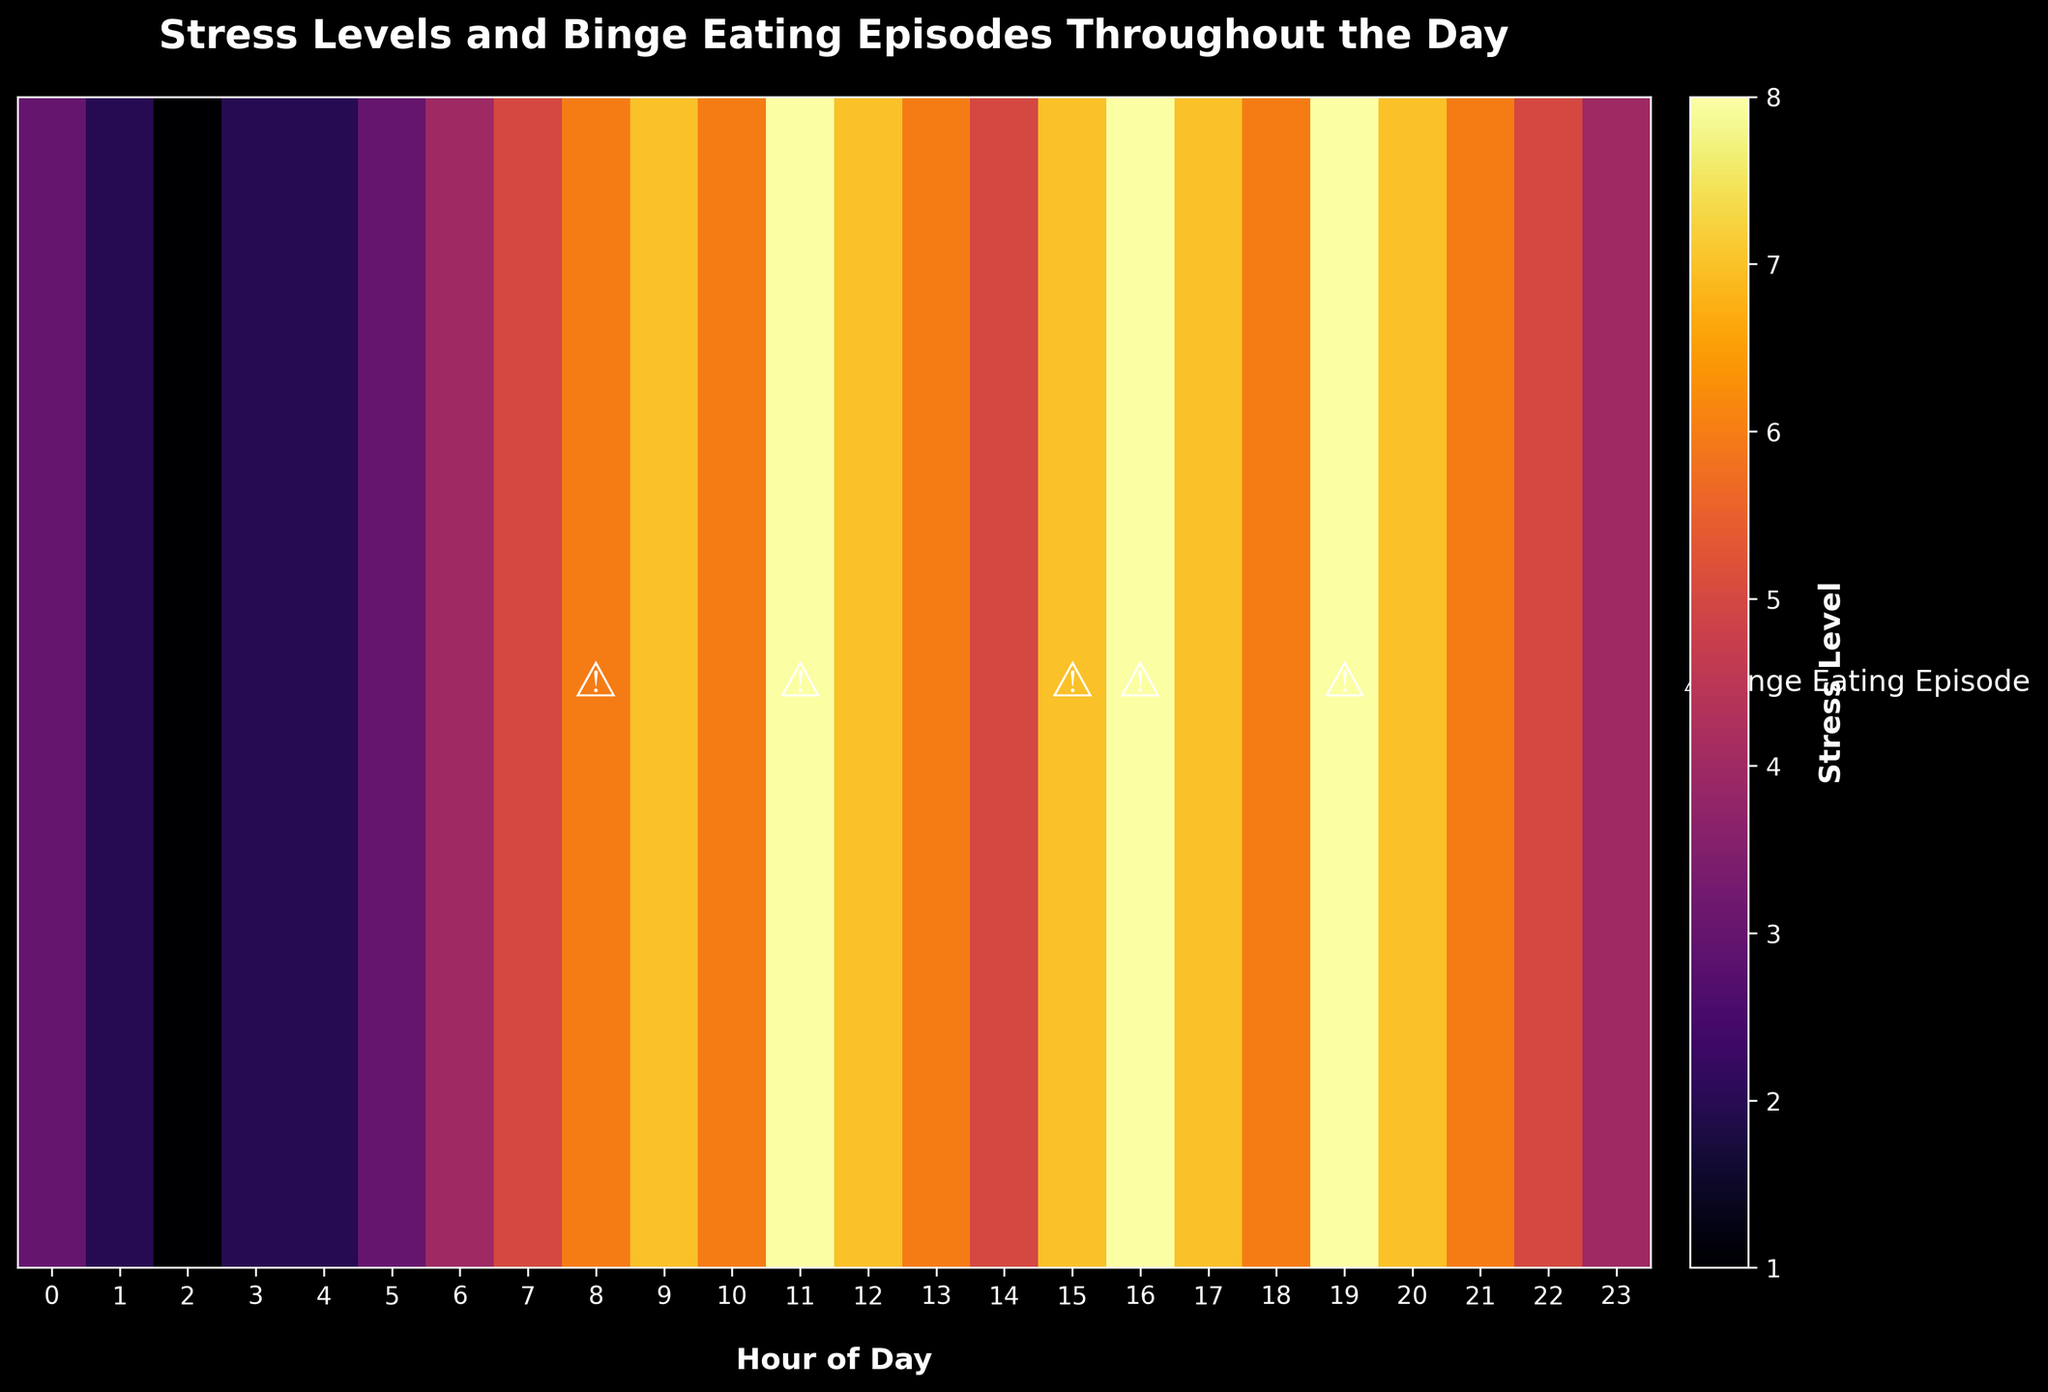What is the title of the heatmap? The title is found at the top of the heatmap. It clearly states the main subject of the visualization.
Answer: Stress Levels and Binge Eating Episodes Throughout the Day At what times do binge eating episodes occur? The binge eating episodes are indicated by the '⚠️' symbol on the heatmap across specific times.
Answer: 08:00, 11:00, 15:00, 16:00, 19:00 What hour has the highest recorded stress level? By examining the heatmap for the highest intensity color and checking the corresponding x-axis label, you can identify this.
Answer: 11:00 and 16:00 How many hours have a stress level of 8? The heatmap color intensity can be cross-referenced with the colorbar to locate all instances where the intensity indicates a stress level of 8.
Answer: 3 hours (11:00, 16:00, and 19:00) Compare the stress levels at 06:00 and 18:00. Which one is higher? Look at the stress level colors or values under 06:00 and 18:00 on the heatmap.
Answer: 06:00 What is the average stress level between 00:00 to 05:00? Sum the stress levels from 00:00 to 05:00 and then divide by the number of hours for the average. The values are: 3, 2, 1, 2, 2, 3. (3+2+1+2+2+3)/6.
Answer: 2.17 How does the stress level at 12:00 compare to the stress level at 21:00? Check the heatmap's corresponding colors or levels for 12:00 and 21:00 and compare them.
Answer: 12:00 is higher Which time period has more binge eating episodes: morning (00:00-11:59) or afternoon (12:00-23:59)? Count the number of '⚠️' symbols in the morning period and in the afternoon period and compare them.
Answer: Afternoon (3 episodes) Is there a correlation between high stress levels and binge eating episodes? Observe the heatmap to see if binge eating indicators generally appear at times with higher stress colors.
Answer: Yes Between which hours does the highest stress level fluctuation occur? By visually inspecting the heatmap, find the period with the greatest variance in color intensity, indicating fluctuations in stress levels.
Answer: 07:00 to 11:00 